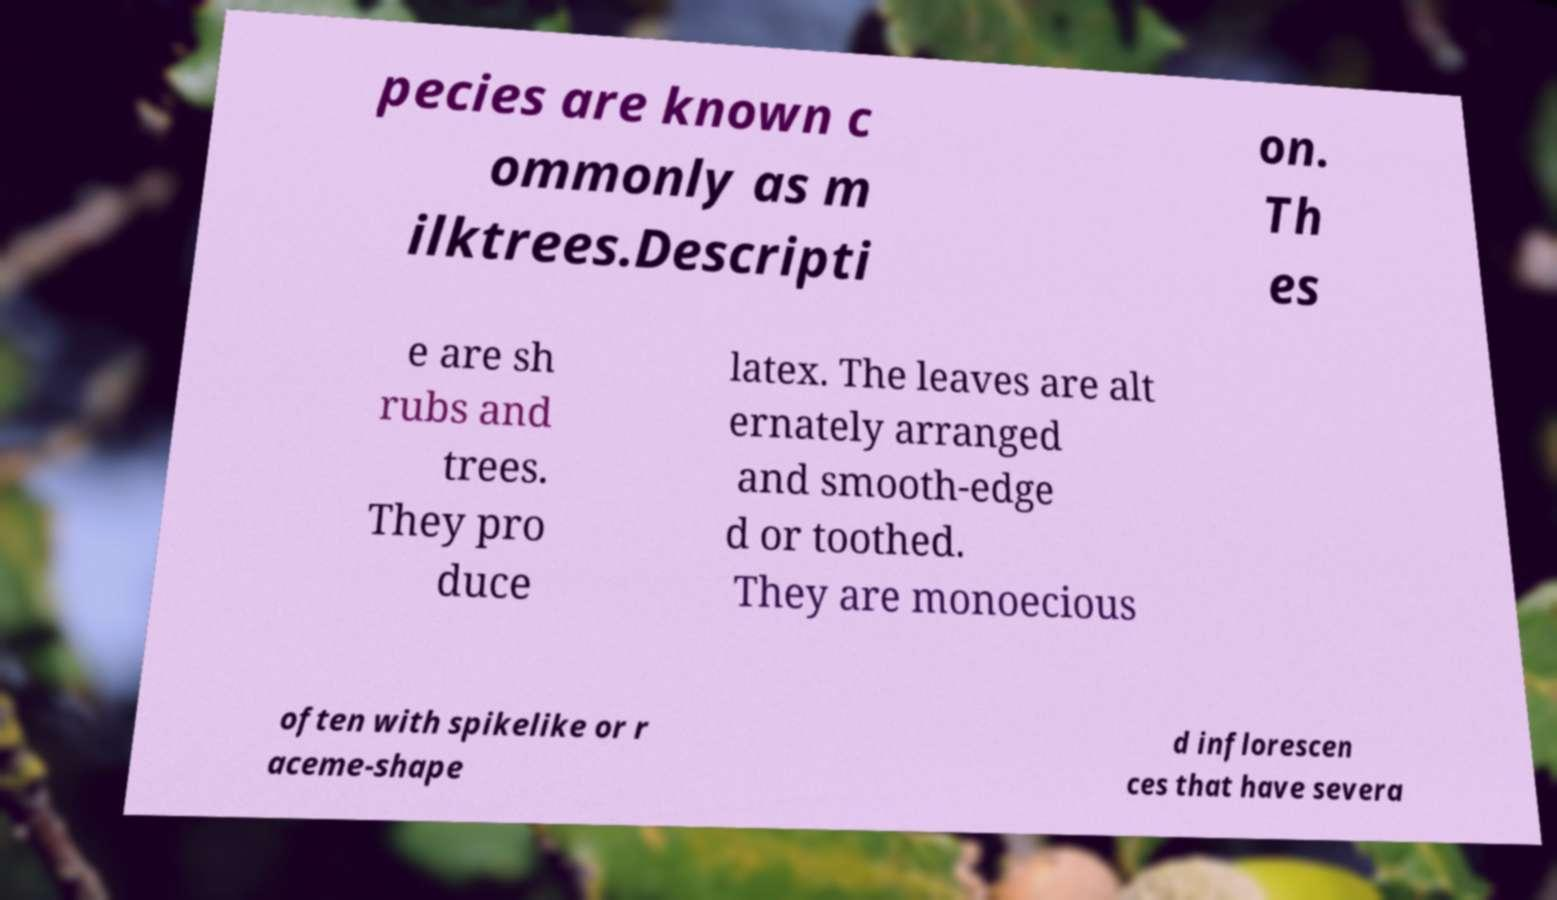Can you read and provide the text displayed in the image?This photo seems to have some interesting text. Can you extract and type it out for me? pecies are known c ommonly as m ilktrees.Descripti on. Th es e are sh rubs and trees. They pro duce latex. The leaves are alt ernately arranged and smooth-edge d or toothed. They are monoecious often with spikelike or r aceme-shape d inflorescen ces that have severa 